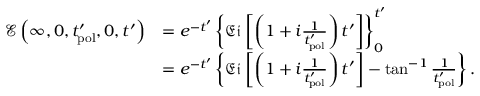Convert formula to latex. <formula><loc_0><loc_0><loc_500><loc_500>\begin{array} { r l } { \mathcal { E } \left ( \infty , 0 , t _ { p o l } ^ { \prime } , 0 , t ^ { \prime } \right ) } & { = e ^ { - t ^ { \prime } } \left \{ \mathfrak { E i } \left [ \left ( 1 + i \frac { 1 } { t _ { p o l } ^ { \prime } } \right ) t ^ { \prime } \right ] \right \} _ { 0 } ^ { t ^ { \prime } } } \\ & { = e ^ { - t ^ { \prime } } \left \{ \mathfrak { E i } \left [ \left ( 1 + i \frac { 1 } { t _ { p o l } ^ { \prime } } \right ) t ^ { \prime } \right ] - \tan ^ { - 1 } { \frac { 1 } { t _ { p o l } ^ { \prime } } } \right \} . } \end{array}</formula> 